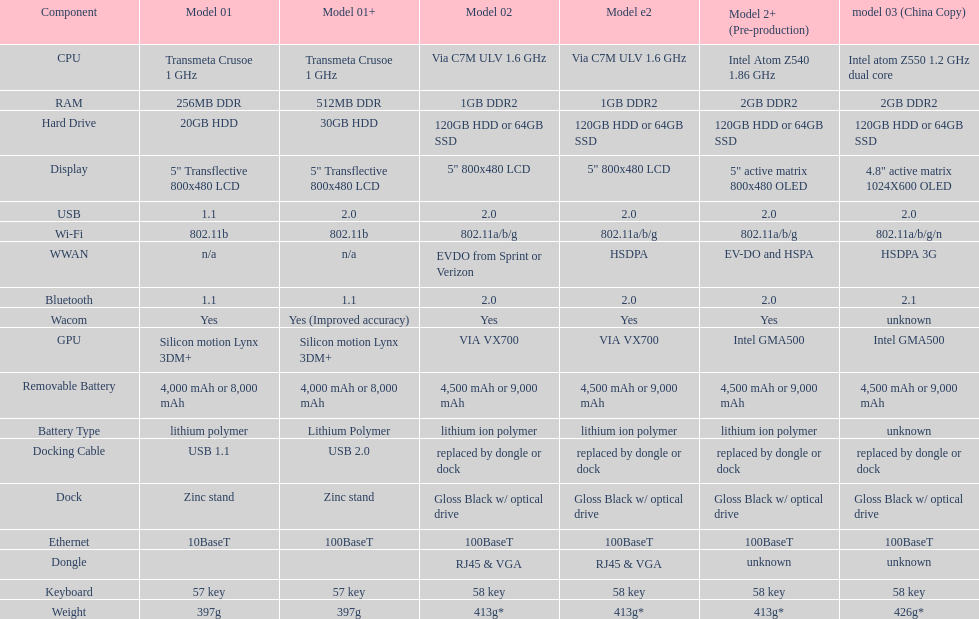Which model offers a bigger hard drive: model 01 or model 02? Model 02. 